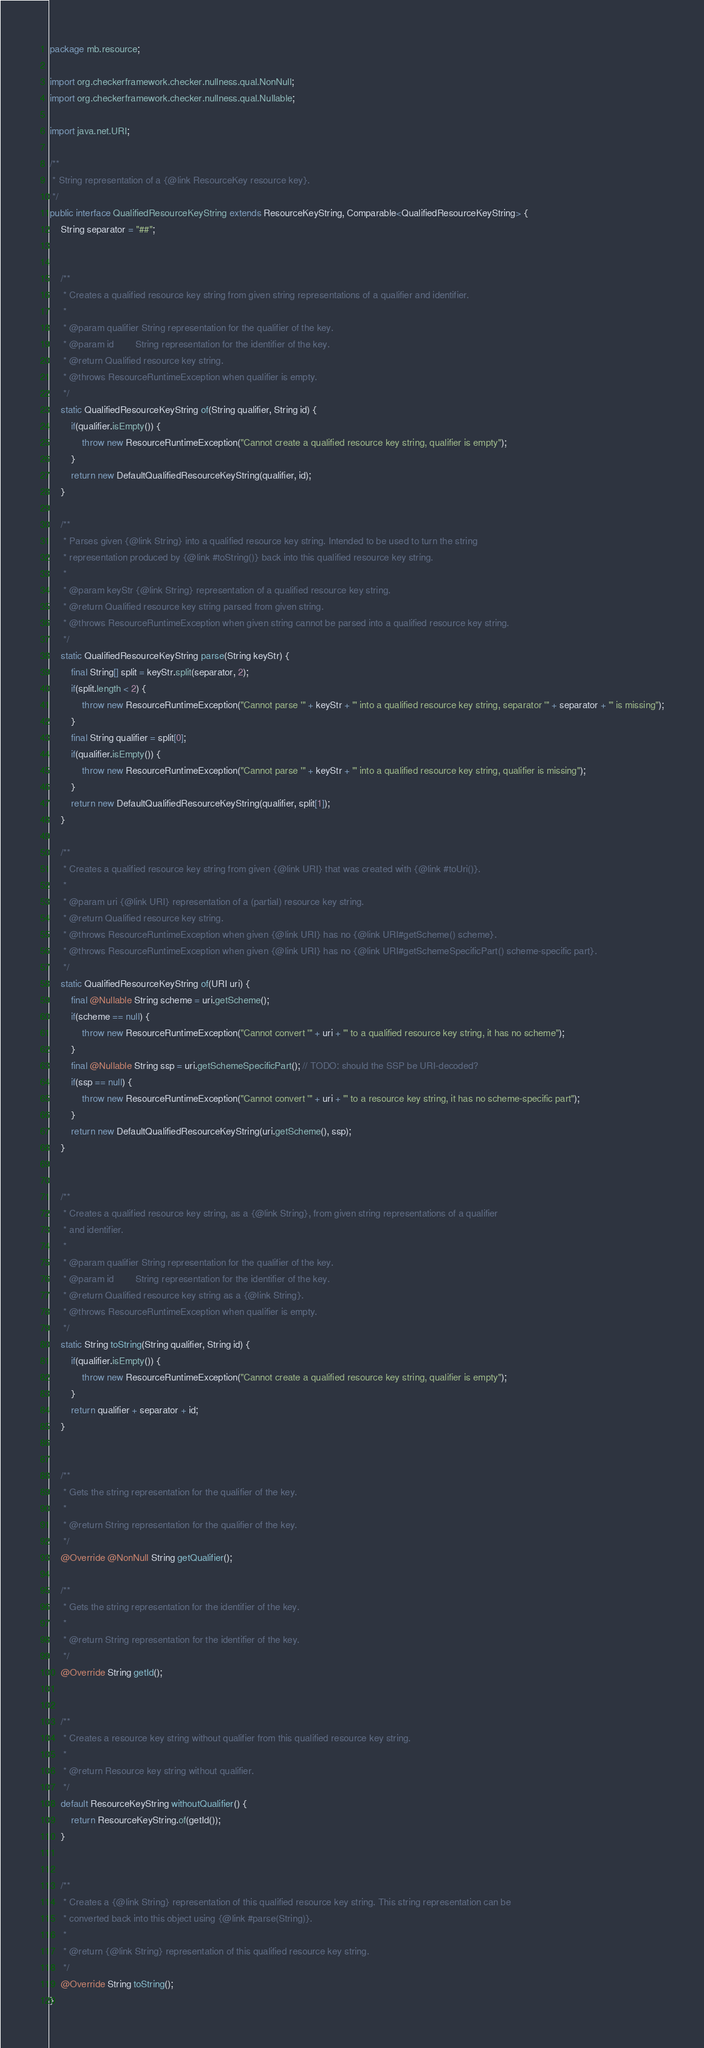<code> <loc_0><loc_0><loc_500><loc_500><_Java_>package mb.resource;

import org.checkerframework.checker.nullness.qual.NonNull;
import org.checkerframework.checker.nullness.qual.Nullable;

import java.net.URI;

/**
 * String representation of a {@link ResourceKey resource key}.
 */
public interface QualifiedResourceKeyString extends ResourceKeyString, Comparable<QualifiedResourceKeyString> {
    String separator = "##";


    /**
     * Creates a qualified resource key string from given string representations of a qualifier and identifier.
     *
     * @param qualifier String representation for the qualifier of the key.
     * @param id        String representation for the identifier of the key.
     * @return Qualified resource key string.
     * @throws ResourceRuntimeException when qualifier is empty.
     */
    static QualifiedResourceKeyString of(String qualifier, String id) {
        if(qualifier.isEmpty()) {
            throw new ResourceRuntimeException("Cannot create a qualified resource key string, qualifier is empty");
        }
        return new DefaultQualifiedResourceKeyString(qualifier, id);
    }

    /**
     * Parses given {@link String} into a qualified resource key string. Intended to be used to turn the string
     * representation produced by {@link #toString()} back into this qualified resource key string.
     *
     * @param keyStr {@link String} representation of a qualified resource key string.
     * @return Qualified resource key string parsed from given string.
     * @throws ResourceRuntimeException when given string cannot be parsed into a qualified resource key string.
     */
    static QualifiedResourceKeyString parse(String keyStr) {
        final String[] split = keyStr.split(separator, 2);
        if(split.length < 2) {
            throw new ResourceRuntimeException("Cannot parse '" + keyStr + "' into a qualified resource key string, separator '" + separator + "' is missing");
        }
        final String qualifier = split[0];
        if(qualifier.isEmpty()) {
            throw new ResourceRuntimeException("Cannot parse '" + keyStr + "' into a qualified resource key string, qualifier is missing");
        }
        return new DefaultQualifiedResourceKeyString(qualifier, split[1]);
    }

    /**
     * Creates a qualified resource key string from given {@link URI} that was created with {@link #toUri()}.
     *
     * @param uri {@link URI} representation of a (partial) resource key string.
     * @return Qualified resource key string.
     * @throws ResourceRuntimeException when given {@link URI} has no {@link URI#getScheme() scheme}.
     * @throws ResourceRuntimeException when given {@link URI} has no {@link URI#getSchemeSpecificPart() scheme-specific part}.
     */
    static QualifiedResourceKeyString of(URI uri) {
        final @Nullable String scheme = uri.getScheme();
        if(scheme == null) {
            throw new ResourceRuntimeException("Cannot convert '" + uri + "' to a qualified resource key string, it has no scheme");
        }
        final @Nullable String ssp = uri.getSchemeSpecificPart(); // TODO: should the SSP be URI-decoded?
        if(ssp == null) {
            throw new ResourceRuntimeException("Cannot convert '" + uri + "' to a resource key string, it has no scheme-specific part");
        }
        return new DefaultQualifiedResourceKeyString(uri.getScheme(), ssp);
    }


    /**
     * Creates a qualified resource key string, as a {@link String}, from given string representations of a qualifier
     * and identifier.
     *
     * @param qualifier String representation for the qualifier of the key.
     * @param id        String representation for the identifier of the key.
     * @return Qualified resource key string as a {@link String}.
     * @throws ResourceRuntimeException when qualifier is empty.
     */
    static String toString(String qualifier, String id) {
        if(qualifier.isEmpty()) {
            throw new ResourceRuntimeException("Cannot create a qualified resource key string, qualifier is empty");
        }
        return qualifier + separator + id;
    }


    /**
     * Gets the string representation for the qualifier of the key.
     *
     * @return String representation for the qualifier of the key.
     */
    @Override @NonNull String getQualifier();

    /**
     * Gets the string representation for the identifier of the key.
     *
     * @return String representation for the identifier of the key.
     */
    @Override String getId();


    /**
     * Creates a resource key string without qualifier from this qualified resource key string.
     *
     * @return Resource key string without qualifier.
     */
    default ResourceKeyString withoutQualifier() {
        return ResourceKeyString.of(getId());
    }


    /**
     * Creates a {@link String} representation of this qualified resource key string. This string representation can be
     * converted back into this object using {@link #parse(String)}.
     *
     * @return {@link String} representation of this qualified resource key string.
     */
    @Override String toString();
}
</code> 